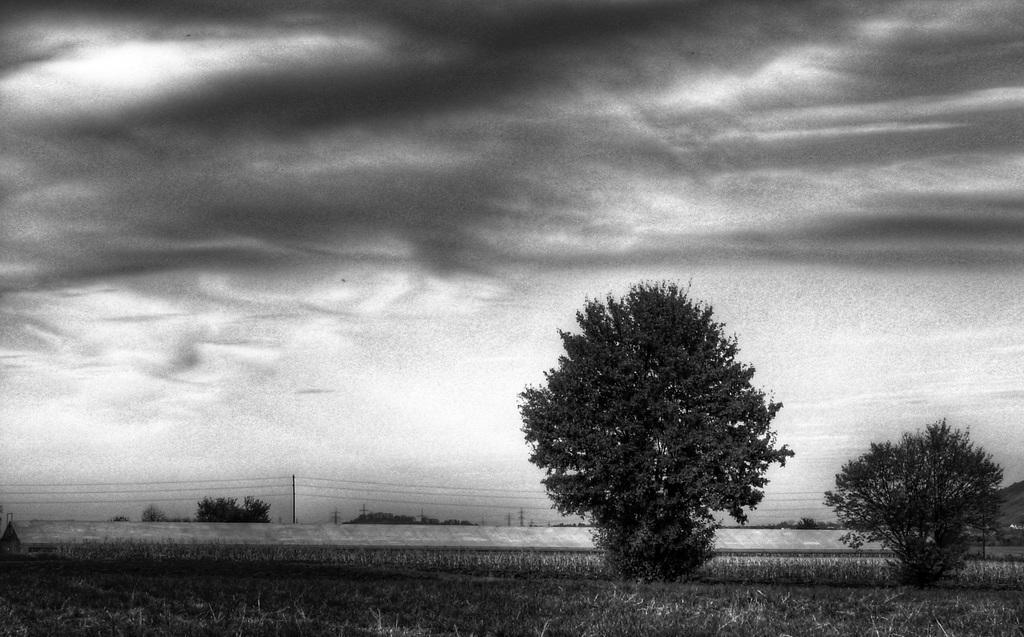In one or two sentences, can you explain what this image depicts? This is a black and white image, there are a few trees, poles, wires. We can see the ground with some grass. We can see the sky with clouds. 